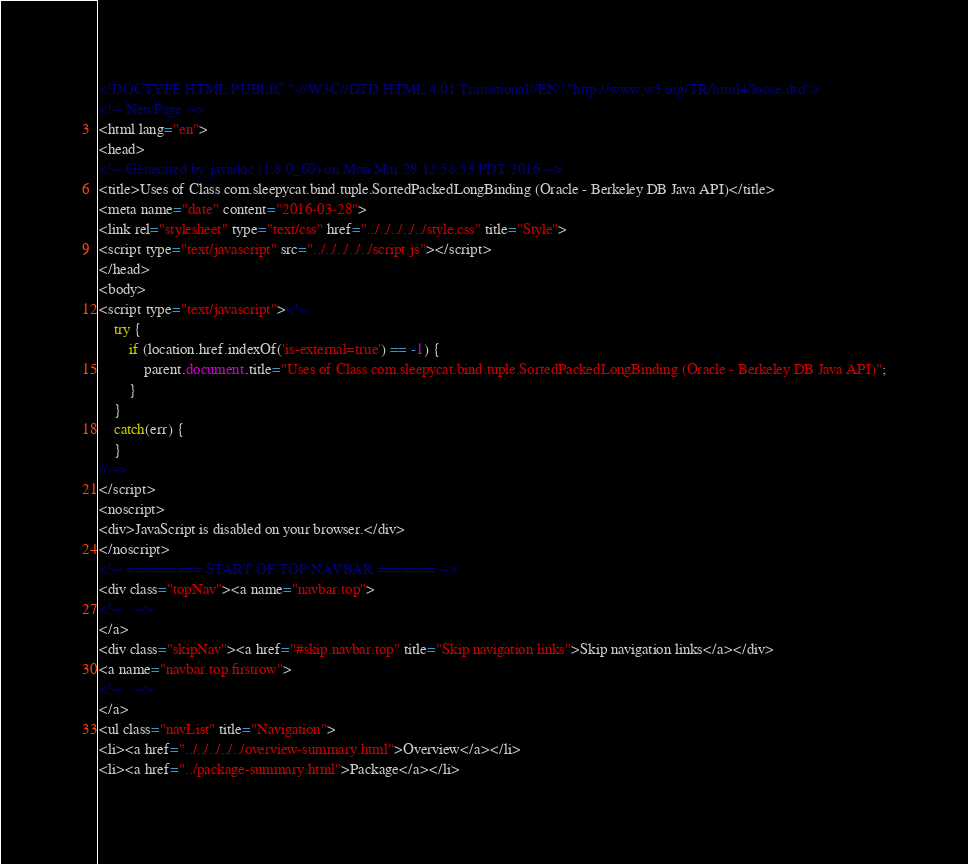Convert code to text. <code><loc_0><loc_0><loc_500><loc_500><_HTML_><!DOCTYPE HTML PUBLIC "-//W3C//DTD HTML 4.01 Transitional//EN" "http://www.w3.org/TR/html4/loose.dtd">
<!-- NewPage -->
<html lang="en">
<head>
<!-- Generated by javadoc (1.8.0_60) on Mon Mar 28 12:58:53 PDT 2016 -->
<title>Uses of Class com.sleepycat.bind.tuple.SortedPackedLongBinding (Oracle - Berkeley DB Java API)</title>
<meta name="date" content="2016-03-28">
<link rel="stylesheet" type="text/css" href="../../../../../style.css" title="Style">
<script type="text/javascript" src="../../../../../script.js"></script>
</head>
<body>
<script type="text/javascript"><!--
    try {
        if (location.href.indexOf('is-external=true') == -1) {
            parent.document.title="Uses of Class com.sleepycat.bind.tuple.SortedPackedLongBinding (Oracle - Berkeley DB Java API)";
        }
    }
    catch(err) {
    }
//-->
</script>
<noscript>
<div>JavaScript is disabled on your browser.</div>
</noscript>
<!-- ========= START OF TOP NAVBAR ======= -->
<div class="topNav"><a name="navbar.top">
<!--   -->
</a>
<div class="skipNav"><a href="#skip.navbar.top" title="Skip navigation links">Skip navigation links</a></div>
<a name="navbar.top.firstrow">
<!--   -->
</a>
<ul class="navList" title="Navigation">
<li><a href="../../../../../overview-summary.html">Overview</a></li>
<li><a href="../package-summary.html">Package</a></li></code> 